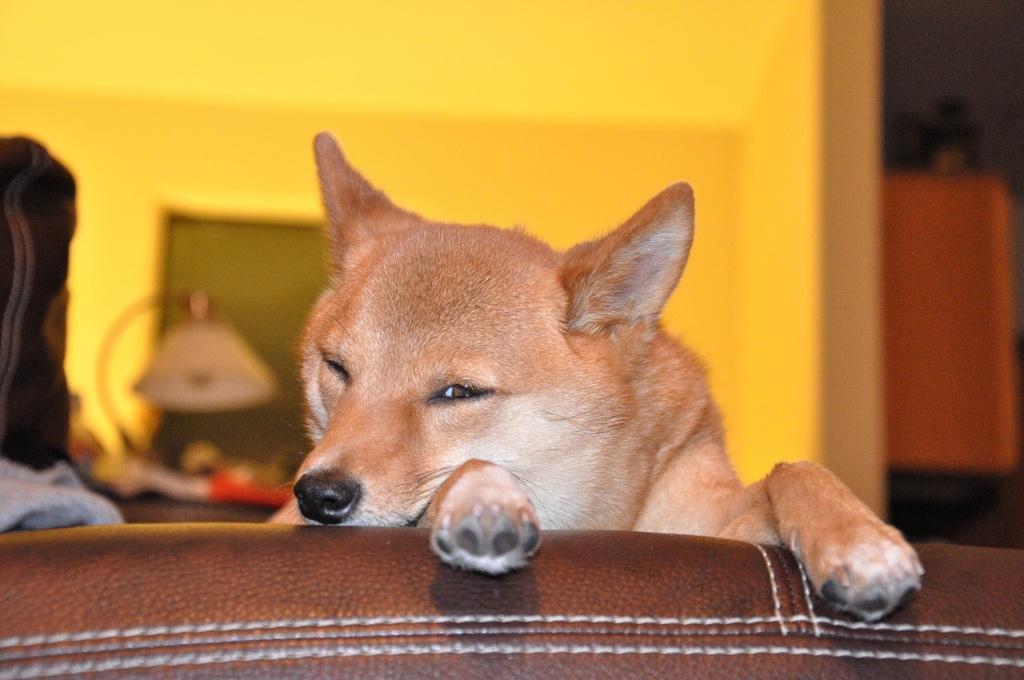Could you give a brief overview of what you see in this image? In this image I can see a dog on a couch. In the background, I can see a monitor is placed on a table and also there is a lamp. On the left side, I can see a cloth which is placed on this couch. 